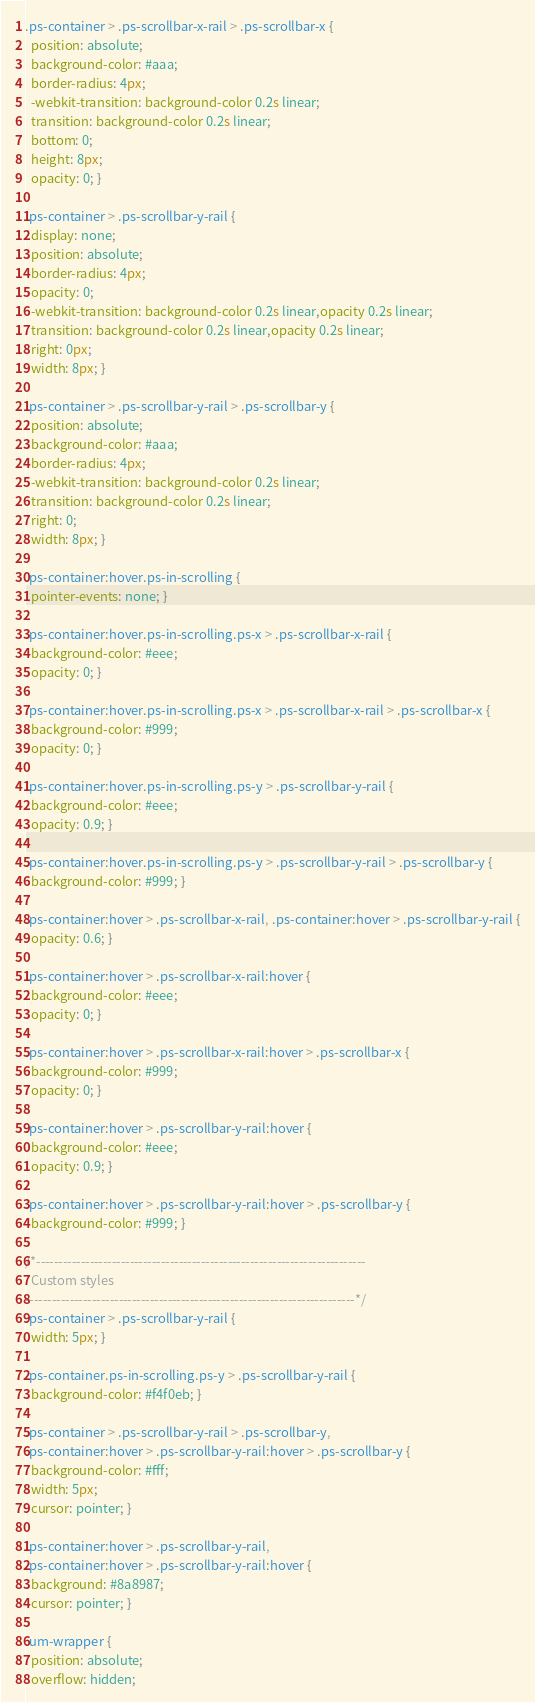Convert code to text. <code><loc_0><loc_0><loc_500><loc_500><_CSS_>.ps-container > .ps-scrollbar-x-rail > .ps-scrollbar-x {
  position: absolute;
  background-color: #aaa;
  border-radius: 4px;
  -webkit-transition: background-color 0.2s linear;
  transition: background-color 0.2s linear;
  bottom: 0;
  height: 8px;
  opacity: 0; }

.ps-container > .ps-scrollbar-y-rail {
  display: none;
  position: absolute;
  border-radius: 4px;
  opacity: 0;
  -webkit-transition: background-color 0.2s linear,opacity 0.2s linear;
  transition: background-color 0.2s linear,opacity 0.2s linear;
  right: 0px;
  width: 8px; }

.ps-container > .ps-scrollbar-y-rail > .ps-scrollbar-y {
  position: absolute;
  background-color: #aaa;
  border-radius: 4px;
  -webkit-transition: background-color 0.2s linear;
  transition: background-color 0.2s linear;
  right: 0;
  width: 8px; }

.ps-container:hover.ps-in-scrolling {
  pointer-events: none; }

.ps-container:hover.ps-in-scrolling.ps-x > .ps-scrollbar-x-rail {
  background-color: #eee;
  opacity: 0; }

.ps-container:hover.ps-in-scrolling.ps-x > .ps-scrollbar-x-rail > .ps-scrollbar-x {
  background-color: #999;
  opacity: 0; }

.ps-container:hover.ps-in-scrolling.ps-y > .ps-scrollbar-y-rail {
  background-color: #eee;
  opacity: 0.9; }

.ps-container:hover.ps-in-scrolling.ps-y > .ps-scrollbar-y-rail > .ps-scrollbar-y {
  background-color: #999; }

.ps-container:hover > .ps-scrollbar-x-rail, .ps-container:hover > .ps-scrollbar-y-rail {
  opacity: 0.6; }

.ps-container:hover > .ps-scrollbar-x-rail:hover {
  background-color: #eee;
  opacity: 0; }

.ps-container:hover > .ps-scrollbar-x-rail:hover > .ps-scrollbar-x {
  background-color: #999;
  opacity: 0; }

.ps-container:hover > .ps-scrollbar-y-rail:hover {
  background-color: #eee;
  opacity: 0.9; }

.ps-container:hover > .ps-scrollbar-y-rail:hover > .ps-scrollbar-y {
  background-color: #999; }

/*--------------------------------------------------------------------------
  Custom styles
--------------------------------------------------------------------------*/
.ps-container > .ps-scrollbar-y-rail {
  width: 5px; }

.ps-container.ps-in-scrolling.ps-y > .ps-scrollbar-y-rail {
  background-color: #f4f0eb; }

.ps-container > .ps-scrollbar-y-rail > .ps-scrollbar-y,
.ps-container:hover > .ps-scrollbar-y-rail:hover > .ps-scrollbar-y {
  background-color: #fff;
  width: 5px;
  cursor: pointer; }

.ps-container:hover > .ps-scrollbar-y-rail,
.ps-container:hover > .ps-scrollbar-y-rail:hover {
  background: #8a8987;
  cursor: pointer; }

.um-wrapper {
  position: absolute;
  overflow: hidden;</code> 